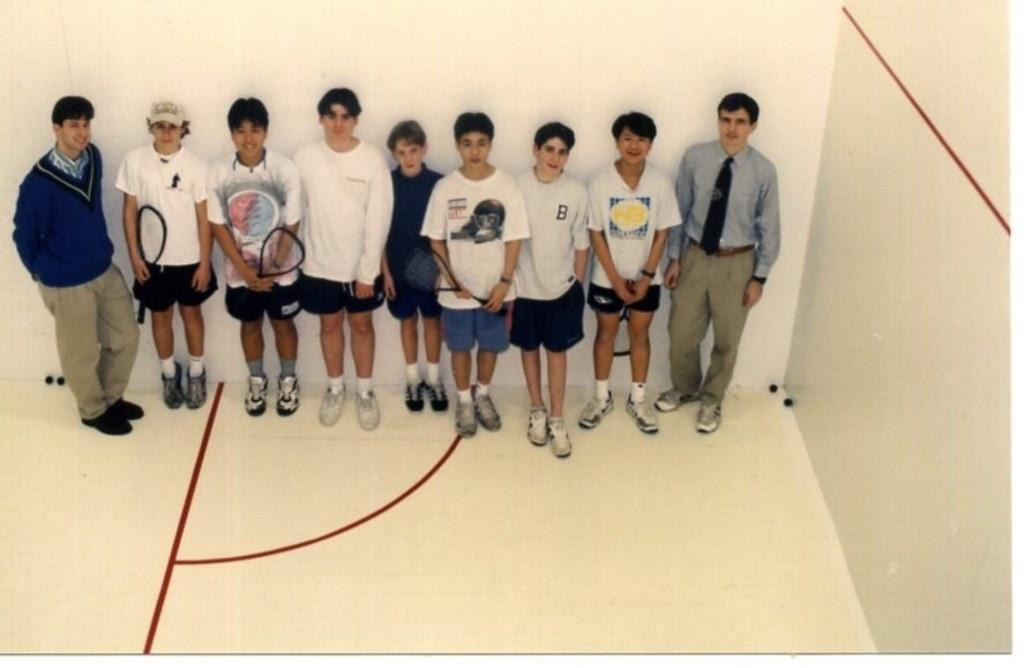How many people are in the image? There are many persons standing in the image. What are two of the persons holding? Two persons are holding tennis rackets. What can be seen in the background of the image? There is a wall in the background of the image. What is on the right side of the image? There is a wall on the right side of the image. What type of clothing accessory is one person wearing? One person is wearing a cap. What type of fruit can be seen hanging from the wall on the right side of the image? There is no fruit, specifically quince, hanging from the wall in the image. What type of vehicles are parked near the persons in the image? There are no vehicles, such as trucks, present in the image. 